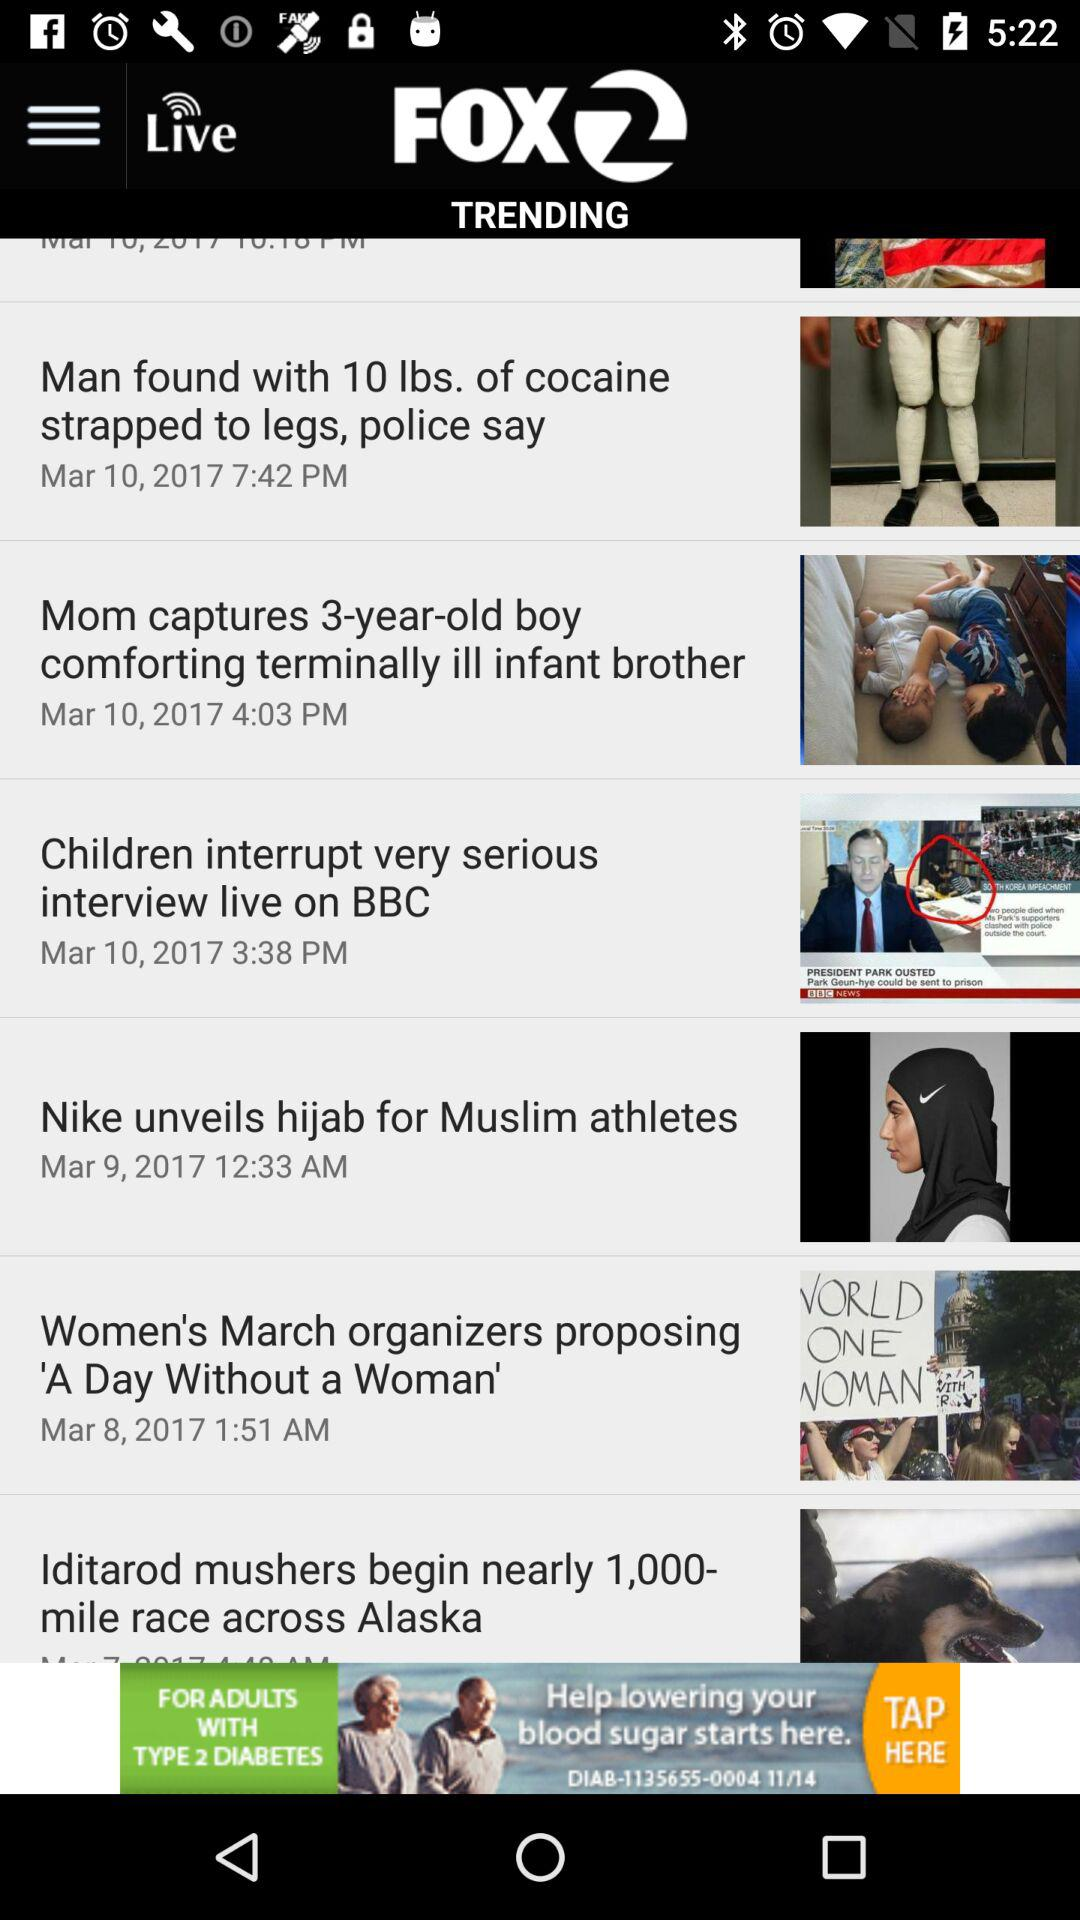What is the publication date of the article "Children interrupt very serious interview live on BBC"? The publication date of the article "Children interrupt very serious interview live on BBC" is March 10, 2017. 